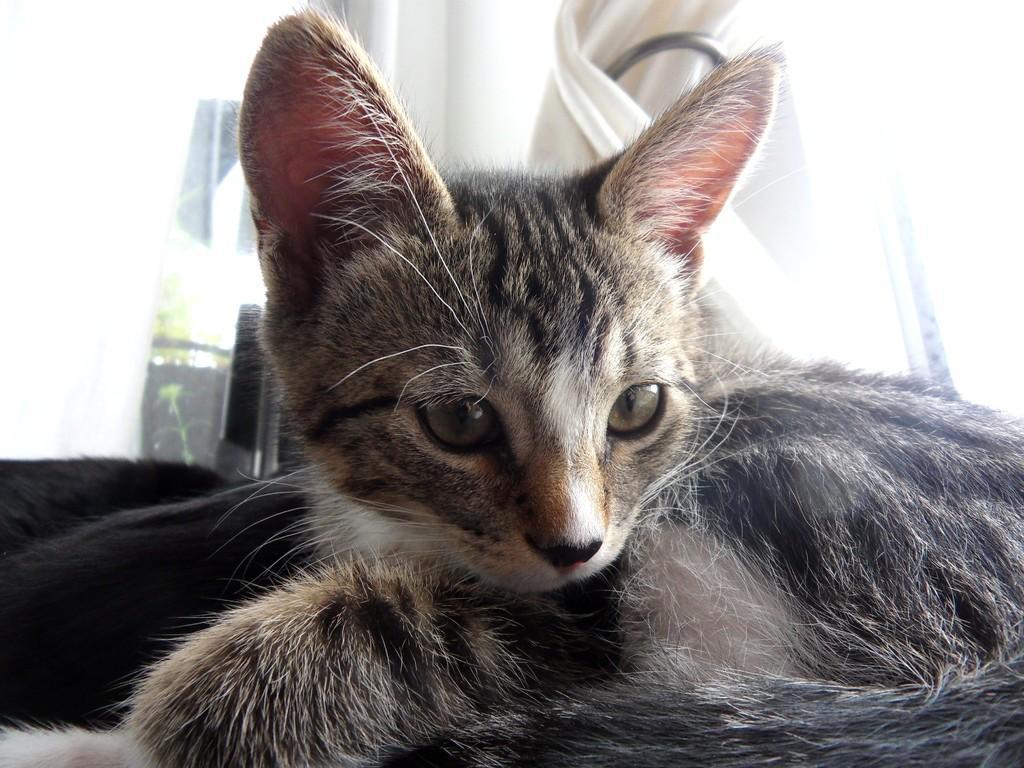Describe this image in one or two sentences. In this image we can see a cat on the surface. On the backside we can see a curtain, plant and a wall. 